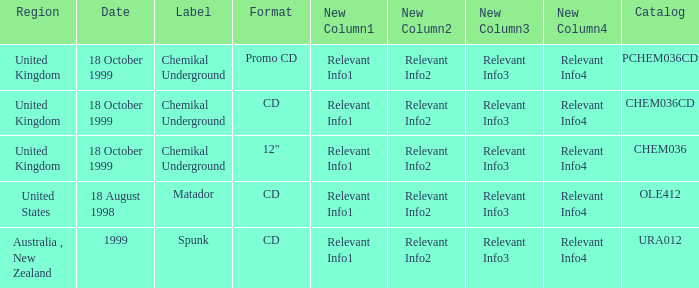Give me the full table as a dictionary. {'header': ['Region', 'Date', 'Label', 'Format', 'New Column1', 'New Column2', 'New Column3', 'New Column4', 'Catalog'], 'rows': [['United Kingdom', '18 October 1999', 'Chemikal Underground', 'Promo CD', 'Relevant Info1', 'Relevant Info2', 'Relevant Info3', 'Relevant Info4', 'PCHEM036CD'], ['United Kingdom', '18 October 1999', 'Chemikal Underground', 'CD', 'Relevant Info1', 'Relevant Info2', 'Relevant Info3', 'Relevant Info4', 'CHEM036CD'], ['United Kingdom', '18 October 1999', 'Chemikal Underground', '12"', 'Relevant Info1', 'Relevant Info2', 'Relevant Info3', 'Relevant Info4', 'CHEM036'], ['United States', '18 August 1998', 'Matador', 'CD', 'Relevant Info1', 'Relevant Info2', 'Relevant Info3', 'Relevant Info4', 'OLE412'], ['Australia , New Zealand', '1999', 'Spunk', 'CD', 'Relevant Info1', 'Relevant Info2', 'Relevant Info3', 'Relevant Info4', 'URA012']]} What label has a catalog of chem036cd? Chemikal Underground. 